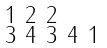Convert formula to latex. <formula><loc_0><loc_0><loc_500><loc_500>\begin{smallmatrix} 1 & 2 & 2 \\ 3 & 4 & 3 & 4 & 1 \end{smallmatrix}</formula> 